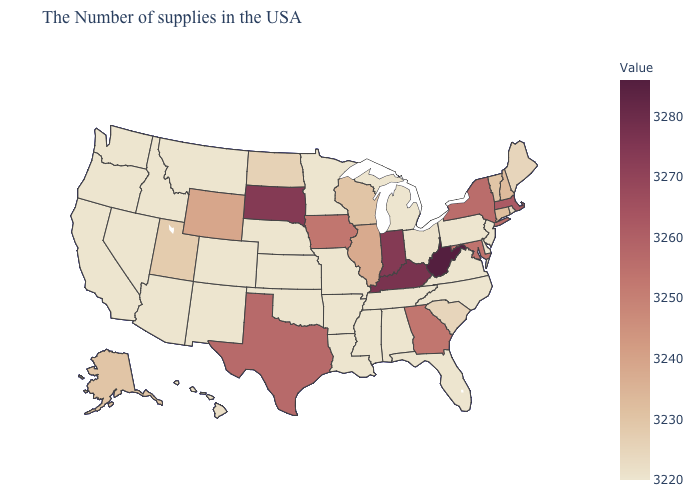Among the states that border North Dakota , does Montana have the highest value?
Concise answer only. No. Among the states that border Vermont , which have the highest value?
Concise answer only. Massachusetts. Does the map have missing data?
Quick response, please. No. Among the states that border Wyoming , which have the highest value?
Give a very brief answer. South Dakota. Which states hav the highest value in the West?
Short answer required. Wyoming. Among the states that border Rhode Island , which have the lowest value?
Concise answer only. Connecticut. 